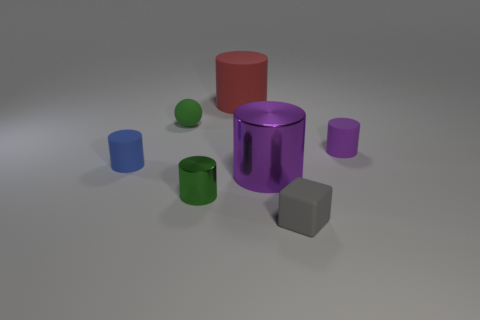There is a small green object that is made of the same material as the red cylinder; what is its shape?
Offer a very short reply. Sphere. Is the number of small green matte objects that are on the right side of the green rubber object less than the number of green balls?
Your response must be concise. Yes. Do the red object and the big purple metallic object have the same shape?
Make the answer very short. Yes. What number of shiny objects are either green cylinders or big things?
Your answer should be very brief. 2. Is there a gray matte object of the same size as the green metallic object?
Provide a succinct answer. Yes. What is the shape of the other tiny object that is the same color as the tiny shiny thing?
Keep it short and to the point. Sphere. What number of green matte balls have the same size as the gray block?
Provide a short and direct response. 1. Is the size of the rubber cylinder that is right of the big red thing the same as the matte thing that is behind the small sphere?
Give a very brief answer. No. How many objects are either green shiny cylinders or small rubber things on the left side of the big red cylinder?
Your answer should be compact. 3. The matte block has what color?
Make the answer very short. Gray. 